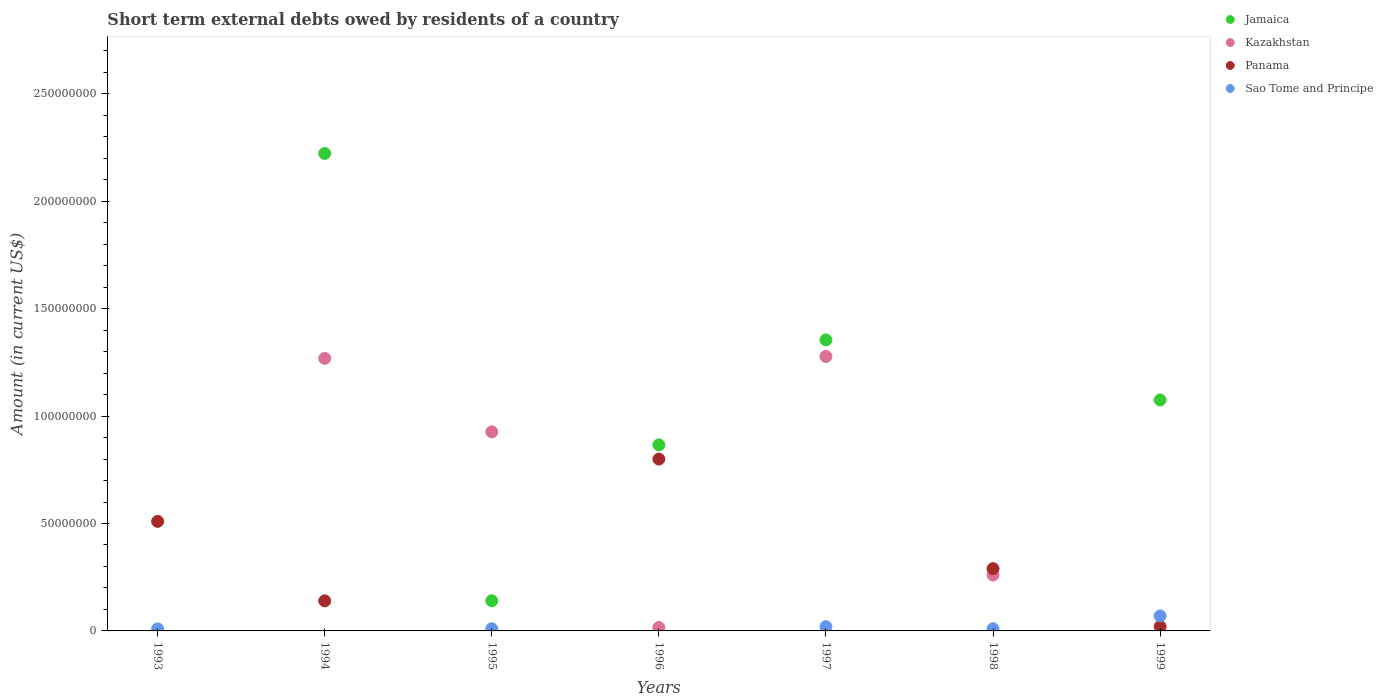How many different coloured dotlines are there?
Offer a terse response. 4. What is the amount of short-term external debts owed by residents in Kazakhstan in 1997?
Offer a very short reply. 1.28e+08. Across all years, what is the maximum amount of short-term external debts owed by residents in Sao Tome and Principe?
Your answer should be very brief. 7.00e+06. In which year was the amount of short-term external debts owed by residents in Panama maximum?
Your response must be concise. 1996. What is the total amount of short-term external debts owed by residents in Jamaica in the graph?
Offer a very short reply. 5.66e+08. What is the difference between the amount of short-term external debts owed by residents in Kazakhstan in 1994 and that in 1995?
Your response must be concise. 3.42e+07. What is the difference between the amount of short-term external debts owed by residents in Kazakhstan in 1995 and the amount of short-term external debts owed by residents in Jamaica in 1999?
Provide a succinct answer. -1.48e+07. What is the average amount of short-term external debts owed by residents in Panama per year?
Your answer should be very brief. 2.51e+07. In the year 1998, what is the difference between the amount of short-term external debts owed by residents in Sao Tome and Principe and amount of short-term external debts owed by residents in Panama?
Your answer should be compact. -2.80e+07. In how many years, is the amount of short-term external debts owed by residents in Sao Tome and Principe greater than 240000000 US$?
Offer a terse response. 0. What is the ratio of the amount of short-term external debts owed by residents in Panama in 1994 to that in 1996?
Offer a terse response. 0.17. Is the amount of short-term external debts owed by residents in Kazakhstan in 1995 less than that in 1997?
Provide a succinct answer. Yes. Is the difference between the amount of short-term external debts owed by residents in Sao Tome and Principe in 1998 and 1999 greater than the difference between the amount of short-term external debts owed by residents in Panama in 1998 and 1999?
Your response must be concise. No. What is the difference between the highest and the second highest amount of short-term external debts owed by residents in Jamaica?
Give a very brief answer. 8.68e+07. What is the difference between the highest and the lowest amount of short-term external debts owed by residents in Kazakhstan?
Give a very brief answer. 1.28e+08. Is it the case that in every year, the sum of the amount of short-term external debts owed by residents in Panama and amount of short-term external debts owed by residents in Jamaica  is greater than the amount of short-term external debts owed by residents in Kazakhstan?
Provide a succinct answer. No. Does the amount of short-term external debts owed by residents in Jamaica monotonically increase over the years?
Ensure brevity in your answer.  No. How many dotlines are there?
Provide a short and direct response. 4. What is the difference between two consecutive major ticks on the Y-axis?
Your response must be concise. 5.00e+07. Does the graph contain any zero values?
Make the answer very short. Yes. How are the legend labels stacked?
Keep it short and to the point. Vertical. What is the title of the graph?
Provide a short and direct response. Short term external debts owed by residents of a country. What is the label or title of the X-axis?
Offer a very short reply. Years. What is the Amount (in current US$) of Jamaica in 1993?
Provide a succinct answer. 0. What is the Amount (in current US$) of Kazakhstan in 1993?
Ensure brevity in your answer.  0. What is the Amount (in current US$) of Panama in 1993?
Your answer should be very brief. 5.10e+07. What is the Amount (in current US$) in Sao Tome and Principe in 1993?
Offer a very short reply. 9.30e+05. What is the Amount (in current US$) of Jamaica in 1994?
Offer a very short reply. 2.22e+08. What is the Amount (in current US$) of Kazakhstan in 1994?
Your answer should be very brief. 1.27e+08. What is the Amount (in current US$) in Panama in 1994?
Provide a short and direct response. 1.40e+07. What is the Amount (in current US$) in Jamaica in 1995?
Offer a very short reply. 1.40e+07. What is the Amount (in current US$) of Kazakhstan in 1995?
Provide a succinct answer. 9.27e+07. What is the Amount (in current US$) of Panama in 1995?
Keep it short and to the point. 0. What is the Amount (in current US$) of Sao Tome and Principe in 1995?
Ensure brevity in your answer.  1.00e+06. What is the Amount (in current US$) in Jamaica in 1996?
Provide a short and direct response. 8.66e+07. What is the Amount (in current US$) in Kazakhstan in 1996?
Make the answer very short. 1.55e+06. What is the Amount (in current US$) of Panama in 1996?
Your answer should be compact. 8.00e+07. What is the Amount (in current US$) in Sao Tome and Principe in 1996?
Keep it short and to the point. 0. What is the Amount (in current US$) of Jamaica in 1997?
Offer a terse response. 1.35e+08. What is the Amount (in current US$) of Kazakhstan in 1997?
Provide a short and direct response. 1.28e+08. What is the Amount (in current US$) of Panama in 1997?
Offer a terse response. 0. What is the Amount (in current US$) of Sao Tome and Principe in 1997?
Give a very brief answer. 1.97e+06. What is the Amount (in current US$) in Jamaica in 1998?
Keep it short and to the point. 0. What is the Amount (in current US$) in Kazakhstan in 1998?
Your answer should be very brief. 2.60e+07. What is the Amount (in current US$) of Panama in 1998?
Your response must be concise. 2.90e+07. What is the Amount (in current US$) of Jamaica in 1999?
Provide a succinct answer. 1.08e+08. What is the Amount (in current US$) in Sao Tome and Principe in 1999?
Offer a terse response. 7.00e+06. Across all years, what is the maximum Amount (in current US$) in Jamaica?
Provide a short and direct response. 2.22e+08. Across all years, what is the maximum Amount (in current US$) of Kazakhstan?
Give a very brief answer. 1.28e+08. Across all years, what is the maximum Amount (in current US$) of Panama?
Your answer should be compact. 8.00e+07. Across all years, what is the maximum Amount (in current US$) in Sao Tome and Principe?
Your response must be concise. 7.00e+06. Across all years, what is the minimum Amount (in current US$) in Jamaica?
Make the answer very short. 0. Across all years, what is the minimum Amount (in current US$) of Kazakhstan?
Offer a terse response. 0. Across all years, what is the minimum Amount (in current US$) in Panama?
Give a very brief answer. 0. What is the total Amount (in current US$) in Jamaica in the graph?
Provide a short and direct response. 5.66e+08. What is the total Amount (in current US$) of Kazakhstan in the graph?
Offer a very short reply. 3.75e+08. What is the total Amount (in current US$) in Panama in the graph?
Offer a very short reply. 1.76e+08. What is the total Amount (in current US$) in Sao Tome and Principe in the graph?
Offer a very short reply. 1.19e+07. What is the difference between the Amount (in current US$) in Panama in 1993 and that in 1994?
Provide a succinct answer. 3.70e+07. What is the difference between the Amount (in current US$) of Panama in 1993 and that in 1996?
Offer a very short reply. -2.90e+07. What is the difference between the Amount (in current US$) of Sao Tome and Principe in 1993 and that in 1997?
Give a very brief answer. -1.04e+06. What is the difference between the Amount (in current US$) in Panama in 1993 and that in 1998?
Give a very brief answer. 2.20e+07. What is the difference between the Amount (in current US$) in Sao Tome and Principe in 1993 and that in 1998?
Your response must be concise. -7.00e+04. What is the difference between the Amount (in current US$) in Panama in 1993 and that in 1999?
Make the answer very short. 4.90e+07. What is the difference between the Amount (in current US$) in Sao Tome and Principe in 1993 and that in 1999?
Your response must be concise. -6.07e+06. What is the difference between the Amount (in current US$) in Jamaica in 1994 and that in 1995?
Ensure brevity in your answer.  2.08e+08. What is the difference between the Amount (in current US$) of Kazakhstan in 1994 and that in 1995?
Your answer should be compact. 3.42e+07. What is the difference between the Amount (in current US$) in Jamaica in 1994 and that in 1996?
Make the answer very short. 1.36e+08. What is the difference between the Amount (in current US$) of Kazakhstan in 1994 and that in 1996?
Give a very brief answer. 1.25e+08. What is the difference between the Amount (in current US$) of Panama in 1994 and that in 1996?
Make the answer very short. -6.60e+07. What is the difference between the Amount (in current US$) in Jamaica in 1994 and that in 1997?
Offer a terse response. 8.68e+07. What is the difference between the Amount (in current US$) in Kazakhstan in 1994 and that in 1997?
Make the answer very short. -8.90e+05. What is the difference between the Amount (in current US$) of Kazakhstan in 1994 and that in 1998?
Keep it short and to the point. 1.01e+08. What is the difference between the Amount (in current US$) of Panama in 1994 and that in 1998?
Provide a short and direct response. -1.50e+07. What is the difference between the Amount (in current US$) of Jamaica in 1994 and that in 1999?
Your response must be concise. 1.15e+08. What is the difference between the Amount (in current US$) in Panama in 1994 and that in 1999?
Your answer should be very brief. 1.20e+07. What is the difference between the Amount (in current US$) in Jamaica in 1995 and that in 1996?
Make the answer very short. -7.26e+07. What is the difference between the Amount (in current US$) in Kazakhstan in 1995 and that in 1996?
Keep it short and to the point. 9.11e+07. What is the difference between the Amount (in current US$) of Jamaica in 1995 and that in 1997?
Keep it short and to the point. -1.21e+08. What is the difference between the Amount (in current US$) of Kazakhstan in 1995 and that in 1997?
Your answer should be compact. -3.51e+07. What is the difference between the Amount (in current US$) of Sao Tome and Principe in 1995 and that in 1997?
Your response must be concise. -9.70e+05. What is the difference between the Amount (in current US$) in Kazakhstan in 1995 and that in 1998?
Keep it short and to the point. 6.67e+07. What is the difference between the Amount (in current US$) in Jamaica in 1995 and that in 1999?
Provide a short and direct response. -9.35e+07. What is the difference between the Amount (in current US$) of Sao Tome and Principe in 1995 and that in 1999?
Offer a very short reply. -6.00e+06. What is the difference between the Amount (in current US$) of Jamaica in 1996 and that in 1997?
Your response must be concise. -4.89e+07. What is the difference between the Amount (in current US$) in Kazakhstan in 1996 and that in 1997?
Keep it short and to the point. -1.26e+08. What is the difference between the Amount (in current US$) in Kazakhstan in 1996 and that in 1998?
Your answer should be compact. -2.45e+07. What is the difference between the Amount (in current US$) in Panama in 1996 and that in 1998?
Your response must be concise. 5.10e+07. What is the difference between the Amount (in current US$) of Jamaica in 1996 and that in 1999?
Provide a succinct answer. -2.09e+07. What is the difference between the Amount (in current US$) of Panama in 1996 and that in 1999?
Your answer should be compact. 7.80e+07. What is the difference between the Amount (in current US$) in Kazakhstan in 1997 and that in 1998?
Offer a very short reply. 1.02e+08. What is the difference between the Amount (in current US$) of Sao Tome and Principe in 1997 and that in 1998?
Offer a terse response. 9.70e+05. What is the difference between the Amount (in current US$) in Jamaica in 1997 and that in 1999?
Keep it short and to the point. 2.80e+07. What is the difference between the Amount (in current US$) of Sao Tome and Principe in 1997 and that in 1999?
Offer a very short reply. -5.03e+06. What is the difference between the Amount (in current US$) in Panama in 1998 and that in 1999?
Ensure brevity in your answer.  2.70e+07. What is the difference between the Amount (in current US$) of Sao Tome and Principe in 1998 and that in 1999?
Ensure brevity in your answer.  -6.00e+06. What is the difference between the Amount (in current US$) of Panama in 1993 and the Amount (in current US$) of Sao Tome and Principe in 1995?
Keep it short and to the point. 5.00e+07. What is the difference between the Amount (in current US$) of Panama in 1993 and the Amount (in current US$) of Sao Tome and Principe in 1997?
Offer a terse response. 4.90e+07. What is the difference between the Amount (in current US$) of Panama in 1993 and the Amount (in current US$) of Sao Tome and Principe in 1999?
Offer a terse response. 4.40e+07. What is the difference between the Amount (in current US$) of Jamaica in 1994 and the Amount (in current US$) of Kazakhstan in 1995?
Provide a succinct answer. 1.30e+08. What is the difference between the Amount (in current US$) of Jamaica in 1994 and the Amount (in current US$) of Sao Tome and Principe in 1995?
Your answer should be compact. 2.21e+08. What is the difference between the Amount (in current US$) of Kazakhstan in 1994 and the Amount (in current US$) of Sao Tome and Principe in 1995?
Offer a very short reply. 1.26e+08. What is the difference between the Amount (in current US$) of Panama in 1994 and the Amount (in current US$) of Sao Tome and Principe in 1995?
Keep it short and to the point. 1.30e+07. What is the difference between the Amount (in current US$) in Jamaica in 1994 and the Amount (in current US$) in Kazakhstan in 1996?
Your response must be concise. 2.21e+08. What is the difference between the Amount (in current US$) in Jamaica in 1994 and the Amount (in current US$) in Panama in 1996?
Provide a short and direct response. 1.42e+08. What is the difference between the Amount (in current US$) of Kazakhstan in 1994 and the Amount (in current US$) of Panama in 1996?
Keep it short and to the point. 4.69e+07. What is the difference between the Amount (in current US$) in Jamaica in 1994 and the Amount (in current US$) in Kazakhstan in 1997?
Provide a succinct answer. 9.45e+07. What is the difference between the Amount (in current US$) of Jamaica in 1994 and the Amount (in current US$) of Sao Tome and Principe in 1997?
Make the answer very short. 2.20e+08. What is the difference between the Amount (in current US$) of Kazakhstan in 1994 and the Amount (in current US$) of Sao Tome and Principe in 1997?
Your answer should be compact. 1.25e+08. What is the difference between the Amount (in current US$) of Panama in 1994 and the Amount (in current US$) of Sao Tome and Principe in 1997?
Offer a terse response. 1.20e+07. What is the difference between the Amount (in current US$) in Jamaica in 1994 and the Amount (in current US$) in Kazakhstan in 1998?
Your answer should be compact. 1.96e+08. What is the difference between the Amount (in current US$) of Jamaica in 1994 and the Amount (in current US$) of Panama in 1998?
Your answer should be very brief. 1.93e+08. What is the difference between the Amount (in current US$) of Jamaica in 1994 and the Amount (in current US$) of Sao Tome and Principe in 1998?
Offer a terse response. 2.21e+08. What is the difference between the Amount (in current US$) of Kazakhstan in 1994 and the Amount (in current US$) of Panama in 1998?
Ensure brevity in your answer.  9.79e+07. What is the difference between the Amount (in current US$) in Kazakhstan in 1994 and the Amount (in current US$) in Sao Tome and Principe in 1998?
Offer a very short reply. 1.26e+08. What is the difference between the Amount (in current US$) of Panama in 1994 and the Amount (in current US$) of Sao Tome and Principe in 1998?
Your answer should be compact. 1.30e+07. What is the difference between the Amount (in current US$) of Jamaica in 1994 and the Amount (in current US$) of Panama in 1999?
Make the answer very short. 2.20e+08. What is the difference between the Amount (in current US$) of Jamaica in 1994 and the Amount (in current US$) of Sao Tome and Principe in 1999?
Provide a short and direct response. 2.15e+08. What is the difference between the Amount (in current US$) in Kazakhstan in 1994 and the Amount (in current US$) in Panama in 1999?
Your answer should be compact. 1.25e+08. What is the difference between the Amount (in current US$) in Kazakhstan in 1994 and the Amount (in current US$) in Sao Tome and Principe in 1999?
Offer a very short reply. 1.20e+08. What is the difference between the Amount (in current US$) of Jamaica in 1995 and the Amount (in current US$) of Kazakhstan in 1996?
Provide a succinct answer. 1.25e+07. What is the difference between the Amount (in current US$) of Jamaica in 1995 and the Amount (in current US$) of Panama in 1996?
Ensure brevity in your answer.  -6.60e+07. What is the difference between the Amount (in current US$) of Kazakhstan in 1995 and the Amount (in current US$) of Panama in 1996?
Your answer should be compact. 1.27e+07. What is the difference between the Amount (in current US$) in Jamaica in 1995 and the Amount (in current US$) in Kazakhstan in 1997?
Ensure brevity in your answer.  -1.14e+08. What is the difference between the Amount (in current US$) in Jamaica in 1995 and the Amount (in current US$) in Sao Tome and Principe in 1997?
Your answer should be very brief. 1.21e+07. What is the difference between the Amount (in current US$) in Kazakhstan in 1995 and the Amount (in current US$) in Sao Tome and Principe in 1997?
Provide a short and direct response. 9.07e+07. What is the difference between the Amount (in current US$) in Jamaica in 1995 and the Amount (in current US$) in Kazakhstan in 1998?
Provide a short and direct response. -1.20e+07. What is the difference between the Amount (in current US$) in Jamaica in 1995 and the Amount (in current US$) in Panama in 1998?
Your answer should be compact. -1.50e+07. What is the difference between the Amount (in current US$) of Jamaica in 1995 and the Amount (in current US$) of Sao Tome and Principe in 1998?
Ensure brevity in your answer.  1.30e+07. What is the difference between the Amount (in current US$) in Kazakhstan in 1995 and the Amount (in current US$) in Panama in 1998?
Give a very brief answer. 6.37e+07. What is the difference between the Amount (in current US$) in Kazakhstan in 1995 and the Amount (in current US$) in Sao Tome and Principe in 1998?
Offer a terse response. 9.17e+07. What is the difference between the Amount (in current US$) in Jamaica in 1995 and the Amount (in current US$) in Panama in 1999?
Keep it short and to the point. 1.20e+07. What is the difference between the Amount (in current US$) of Jamaica in 1995 and the Amount (in current US$) of Sao Tome and Principe in 1999?
Provide a succinct answer. 7.03e+06. What is the difference between the Amount (in current US$) in Kazakhstan in 1995 and the Amount (in current US$) in Panama in 1999?
Keep it short and to the point. 9.07e+07. What is the difference between the Amount (in current US$) in Kazakhstan in 1995 and the Amount (in current US$) in Sao Tome and Principe in 1999?
Make the answer very short. 8.57e+07. What is the difference between the Amount (in current US$) in Jamaica in 1996 and the Amount (in current US$) in Kazakhstan in 1997?
Offer a terse response. -4.12e+07. What is the difference between the Amount (in current US$) in Jamaica in 1996 and the Amount (in current US$) in Sao Tome and Principe in 1997?
Give a very brief answer. 8.46e+07. What is the difference between the Amount (in current US$) of Kazakhstan in 1996 and the Amount (in current US$) of Sao Tome and Principe in 1997?
Provide a short and direct response. -4.20e+05. What is the difference between the Amount (in current US$) in Panama in 1996 and the Amount (in current US$) in Sao Tome and Principe in 1997?
Your response must be concise. 7.80e+07. What is the difference between the Amount (in current US$) in Jamaica in 1996 and the Amount (in current US$) in Kazakhstan in 1998?
Give a very brief answer. 6.06e+07. What is the difference between the Amount (in current US$) of Jamaica in 1996 and the Amount (in current US$) of Panama in 1998?
Make the answer very short. 5.76e+07. What is the difference between the Amount (in current US$) in Jamaica in 1996 and the Amount (in current US$) in Sao Tome and Principe in 1998?
Your answer should be compact. 8.56e+07. What is the difference between the Amount (in current US$) of Kazakhstan in 1996 and the Amount (in current US$) of Panama in 1998?
Give a very brief answer. -2.74e+07. What is the difference between the Amount (in current US$) of Panama in 1996 and the Amount (in current US$) of Sao Tome and Principe in 1998?
Your answer should be compact. 7.90e+07. What is the difference between the Amount (in current US$) of Jamaica in 1996 and the Amount (in current US$) of Panama in 1999?
Offer a very short reply. 8.46e+07. What is the difference between the Amount (in current US$) in Jamaica in 1996 and the Amount (in current US$) in Sao Tome and Principe in 1999?
Ensure brevity in your answer.  7.96e+07. What is the difference between the Amount (in current US$) in Kazakhstan in 1996 and the Amount (in current US$) in Panama in 1999?
Your response must be concise. -4.50e+05. What is the difference between the Amount (in current US$) in Kazakhstan in 1996 and the Amount (in current US$) in Sao Tome and Principe in 1999?
Provide a succinct answer. -5.45e+06. What is the difference between the Amount (in current US$) of Panama in 1996 and the Amount (in current US$) of Sao Tome and Principe in 1999?
Your answer should be very brief. 7.30e+07. What is the difference between the Amount (in current US$) in Jamaica in 1997 and the Amount (in current US$) in Kazakhstan in 1998?
Provide a short and direct response. 1.09e+08. What is the difference between the Amount (in current US$) of Jamaica in 1997 and the Amount (in current US$) of Panama in 1998?
Offer a terse response. 1.06e+08. What is the difference between the Amount (in current US$) in Jamaica in 1997 and the Amount (in current US$) in Sao Tome and Principe in 1998?
Your answer should be very brief. 1.34e+08. What is the difference between the Amount (in current US$) in Kazakhstan in 1997 and the Amount (in current US$) in Panama in 1998?
Give a very brief answer. 9.88e+07. What is the difference between the Amount (in current US$) in Kazakhstan in 1997 and the Amount (in current US$) in Sao Tome and Principe in 1998?
Keep it short and to the point. 1.27e+08. What is the difference between the Amount (in current US$) of Jamaica in 1997 and the Amount (in current US$) of Panama in 1999?
Make the answer very short. 1.33e+08. What is the difference between the Amount (in current US$) of Jamaica in 1997 and the Amount (in current US$) of Sao Tome and Principe in 1999?
Keep it short and to the point. 1.28e+08. What is the difference between the Amount (in current US$) of Kazakhstan in 1997 and the Amount (in current US$) of Panama in 1999?
Your answer should be compact. 1.26e+08. What is the difference between the Amount (in current US$) in Kazakhstan in 1997 and the Amount (in current US$) in Sao Tome and Principe in 1999?
Provide a succinct answer. 1.21e+08. What is the difference between the Amount (in current US$) in Kazakhstan in 1998 and the Amount (in current US$) in Panama in 1999?
Offer a terse response. 2.40e+07. What is the difference between the Amount (in current US$) in Kazakhstan in 1998 and the Amount (in current US$) in Sao Tome and Principe in 1999?
Give a very brief answer. 1.90e+07. What is the difference between the Amount (in current US$) of Panama in 1998 and the Amount (in current US$) of Sao Tome and Principe in 1999?
Your answer should be compact. 2.20e+07. What is the average Amount (in current US$) of Jamaica per year?
Keep it short and to the point. 8.08e+07. What is the average Amount (in current US$) in Kazakhstan per year?
Offer a terse response. 5.36e+07. What is the average Amount (in current US$) in Panama per year?
Keep it short and to the point. 2.51e+07. What is the average Amount (in current US$) of Sao Tome and Principe per year?
Offer a very short reply. 1.70e+06. In the year 1993, what is the difference between the Amount (in current US$) in Panama and Amount (in current US$) in Sao Tome and Principe?
Your answer should be compact. 5.01e+07. In the year 1994, what is the difference between the Amount (in current US$) in Jamaica and Amount (in current US$) in Kazakhstan?
Provide a short and direct response. 9.54e+07. In the year 1994, what is the difference between the Amount (in current US$) of Jamaica and Amount (in current US$) of Panama?
Make the answer very short. 2.08e+08. In the year 1994, what is the difference between the Amount (in current US$) of Kazakhstan and Amount (in current US$) of Panama?
Provide a succinct answer. 1.13e+08. In the year 1995, what is the difference between the Amount (in current US$) of Jamaica and Amount (in current US$) of Kazakhstan?
Offer a very short reply. -7.87e+07. In the year 1995, what is the difference between the Amount (in current US$) in Jamaica and Amount (in current US$) in Sao Tome and Principe?
Your answer should be very brief. 1.30e+07. In the year 1995, what is the difference between the Amount (in current US$) in Kazakhstan and Amount (in current US$) in Sao Tome and Principe?
Offer a terse response. 9.17e+07. In the year 1996, what is the difference between the Amount (in current US$) in Jamaica and Amount (in current US$) in Kazakhstan?
Your response must be concise. 8.50e+07. In the year 1996, what is the difference between the Amount (in current US$) of Jamaica and Amount (in current US$) of Panama?
Make the answer very short. 6.60e+06. In the year 1996, what is the difference between the Amount (in current US$) in Kazakhstan and Amount (in current US$) in Panama?
Keep it short and to the point. -7.84e+07. In the year 1997, what is the difference between the Amount (in current US$) in Jamaica and Amount (in current US$) in Kazakhstan?
Make the answer very short. 7.71e+06. In the year 1997, what is the difference between the Amount (in current US$) in Jamaica and Amount (in current US$) in Sao Tome and Principe?
Your answer should be very brief. 1.34e+08. In the year 1997, what is the difference between the Amount (in current US$) of Kazakhstan and Amount (in current US$) of Sao Tome and Principe?
Offer a terse response. 1.26e+08. In the year 1998, what is the difference between the Amount (in current US$) of Kazakhstan and Amount (in current US$) of Panama?
Ensure brevity in your answer.  -2.98e+06. In the year 1998, what is the difference between the Amount (in current US$) of Kazakhstan and Amount (in current US$) of Sao Tome and Principe?
Your answer should be compact. 2.50e+07. In the year 1998, what is the difference between the Amount (in current US$) of Panama and Amount (in current US$) of Sao Tome and Principe?
Offer a very short reply. 2.80e+07. In the year 1999, what is the difference between the Amount (in current US$) of Jamaica and Amount (in current US$) of Panama?
Your answer should be very brief. 1.06e+08. In the year 1999, what is the difference between the Amount (in current US$) of Jamaica and Amount (in current US$) of Sao Tome and Principe?
Your answer should be compact. 1.01e+08. In the year 1999, what is the difference between the Amount (in current US$) in Panama and Amount (in current US$) in Sao Tome and Principe?
Your response must be concise. -5.00e+06. What is the ratio of the Amount (in current US$) in Panama in 1993 to that in 1994?
Ensure brevity in your answer.  3.64. What is the ratio of the Amount (in current US$) of Sao Tome and Principe in 1993 to that in 1995?
Offer a very short reply. 0.93. What is the ratio of the Amount (in current US$) of Panama in 1993 to that in 1996?
Ensure brevity in your answer.  0.64. What is the ratio of the Amount (in current US$) of Sao Tome and Principe in 1993 to that in 1997?
Give a very brief answer. 0.47. What is the ratio of the Amount (in current US$) in Panama in 1993 to that in 1998?
Provide a short and direct response. 1.76. What is the ratio of the Amount (in current US$) in Sao Tome and Principe in 1993 to that in 1998?
Keep it short and to the point. 0.93. What is the ratio of the Amount (in current US$) of Sao Tome and Principe in 1993 to that in 1999?
Keep it short and to the point. 0.13. What is the ratio of the Amount (in current US$) of Jamaica in 1994 to that in 1995?
Your response must be concise. 15.84. What is the ratio of the Amount (in current US$) in Kazakhstan in 1994 to that in 1995?
Keep it short and to the point. 1.37. What is the ratio of the Amount (in current US$) of Jamaica in 1994 to that in 1996?
Provide a succinct answer. 2.57. What is the ratio of the Amount (in current US$) in Kazakhstan in 1994 to that in 1996?
Make the answer very short. 81.85. What is the ratio of the Amount (in current US$) of Panama in 1994 to that in 1996?
Provide a succinct answer. 0.17. What is the ratio of the Amount (in current US$) in Jamaica in 1994 to that in 1997?
Provide a short and direct response. 1.64. What is the ratio of the Amount (in current US$) in Kazakhstan in 1994 to that in 1997?
Your answer should be very brief. 0.99. What is the ratio of the Amount (in current US$) of Kazakhstan in 1994 to that in 1998?
Keep it short and to the point. 4.88. What is the ratio of the Amount (in current US$) of Panama in 1994 to that in 1998?
Your response must be concise. 0.48. What is the ratio of the Amount (in current US$) of Jamaica in 1994 to that in 1999?
Your response must be concise. 2.07. What is the ratio of the Amount (in current US$) in Panama in 1994 to that in 1999?
Give a very brief answer. 7. What is the ratio of the Amount (in current US$) in Jamaica in 1995 to that in 1996?
Offer a terse response. 0.16. What is the ratio of the Amount (in current US$) in Kazakhstan in 1995 to that in 1996?
Offer a very short reply. 59.8. What is the ratio of the Amount (in current US$) in Jamaica in 1995 to that in 1997?
Your answer should be very brief. 0.1. What is the ratio of the Amount (in current US$) of Kazakhstan in 1995 to that in 1997?
Ensure brevity in your answer.  0.73. What is the ratio of the Amount (in current US$) of Sao Tome and Principe in 1995 to that in 1997?
Your answer should be very brief. 0.51. What is the ratio of the Amount (in current US$) of Kazakhstan in 1995 to that in 1998?
Your response must be concise. 3.56. What is the ratio of the Amount (in current US$) of Sao Tome and Principe in 1995 to that in 1998?
Ensure brevity in your answer.  1. What is the ratio of the Amount (in current US$) in Jamaica in 1995 to that in 1999?
Keep it short and to the point. 0.13. What is the ratio of the Amount (in current US$) of Sao Tome and Principe in 1995 to that in 1999?
Give a very brief answer. 0.14. What is the ratio of the Amount (in current US$) of Jamaica in 1996 to that in 1997?
Provide a succinct answer. 0.64. What is the ratio of the Amount (in current US$) in Kazakhstan in 1996 to that in 1997?
Offer a terse response. 0.01. What is the ratio of the Amount (in current US$) in Kazakhstan in 1996 to that in 1998?
Offer a very short reply. 0.06. What is the ratio of the Amount (in current US$) in Panama in 1996 to that in 1998?
Your answer should be compact. 2.76. What is the ratio of the Amount (in current US$) of Jamaica in 1996 to that in 1999?
Your response must be concise. 0.81. What is the ratio of the Amount (in current US$) of Kazakhstan in 1997 to that in 1998?
Keep it short and to the point. 4.91. What is the ratio of the Amount (in current US$) of Sao Tome and Principe in 1997 to that in 1998?
Provide a short and direct response. 1.97. What is the ratio of the Amount (in current US$) in Jamaica in 1997 to that in 1999?
Keep it short and to the point. 1.26. What is the ratio of the Amount (in current US$) of Sao Tome and Principe in 1997 to that in 1999?
Keep it short and to the point. 0.28. What is the ratio of the Amount (in current US$) in Sao Tome and Principe in 1998 to that in 1999?
Keep it short and to the point. 0.14. What is the difference between the highest and the second highest Amount (in current US$) of Jamaica?
Ensure brevity in your answer.  8.68e+07. What is the difference between the highest and the second highest Amount (in current US$) in Kazakhstan?
Provide a short and direct response. 8.90e+05. What is the difference between the highest and the second highest Amount (in current US$) in Panama?
Give a very brief answer. 2.90e+07. What is the difference between the highest and the second highest Amount (in current US$) of Sao Tome and Principe?
Offer a terse response. 5.03e+06. What is the difference between the highest and the lowest Amount (in current US$) of Jamaica?
Give a very brief answer. 2.22e+08. What is the difference between the highest and the lowest Amount (in current US$) of Kazakhstan?
Your response must be concise. 1.28e+08. What is the difference between the highest and the lowest Amount (in current US$) of Panama?
Keep it short and to the point. 8.00e+07. What is the difference between the highest and the lowest Amount (in current US$) in Sao Tome and Principe?
Your response must be concise. 7.00e+06. 